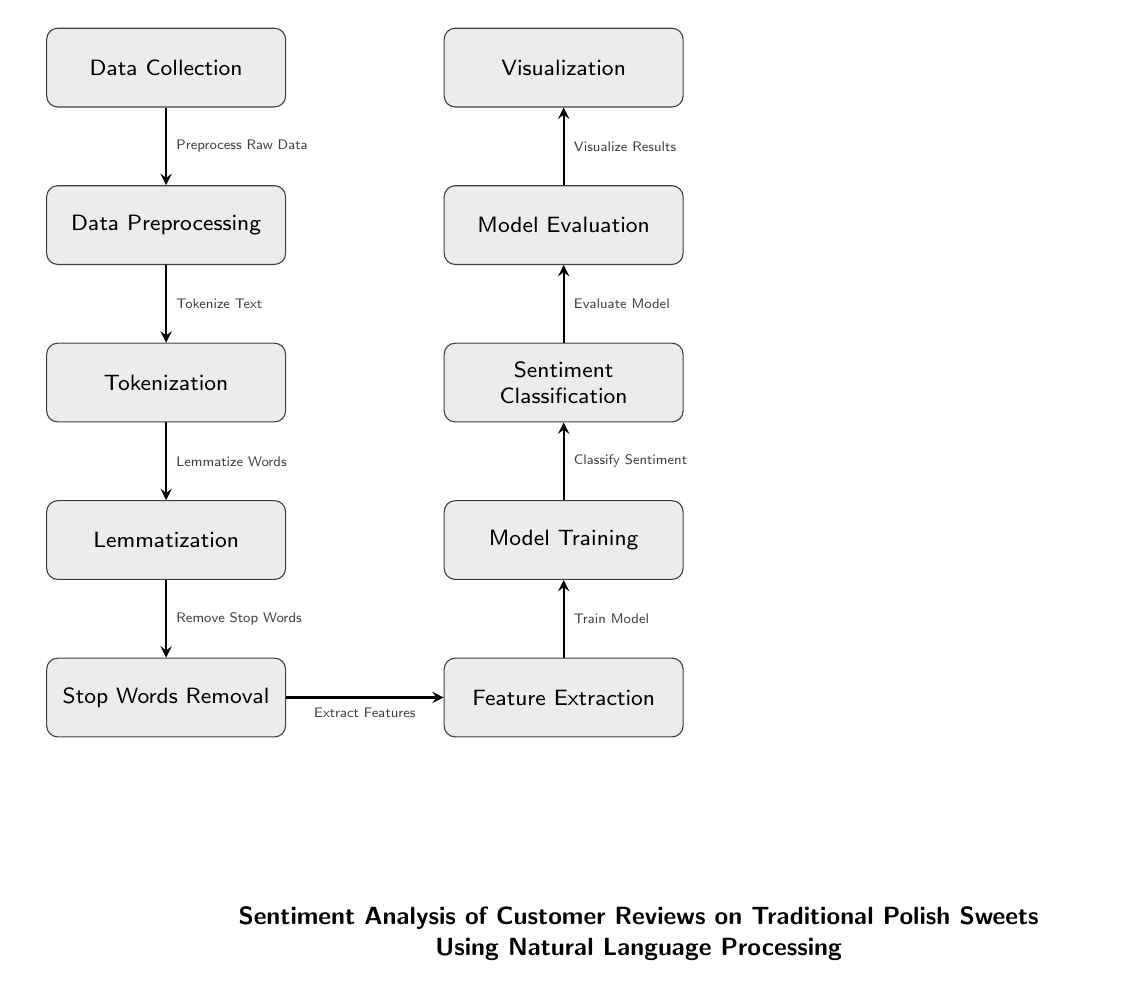What is the first step in the process? The diagram shows "Data Collection" as the first node at the top, where the process begins.
Answer: Data Collection How many processing steps are there? By counting the nodes that represent processing steps from Data Collection to Visualization, there are a total of seven steps.
Answer: Seven What follows after Lemmatization? The diagram indicates that "Stop Words Removal" follows directly after "Lemmatization."
Answer: Stop Words Removal What is the last step in the process? The final node displayed in the diagram is "Visualization," making it the last step in the process.
Answer: Visualization Which process leads to Feature Extraction? "Stop Words Removal" is the preceding process that leads directly into "Feature Extraction," as shown by the arrow connecting those two nodes.
Answer: Stop Words Removal What action occurs after Model Training? According to the diagram, the action that occurs immediately after "Model Training" is "Sentiment Classification."
Answer: Sentiment Classification How are the processes connected visually? The processes are connected by arrows, indicating the flow from one process to another in a step-by-step manner.
Answer: Arrows Which process is to the right of Tokenization? "Feature Extraction" is the process that is positioned directly to the right of the "Tokenization" node in the diagram.
Answer: Feature Extraction What is the purpose of the entire diagram? The title below the nodes states that the diagram is for conducting "Sentiment Analysis of Customer Reviews on Traditional Polish Sweets Using Natural Language Processing."
Answer: Sentiment Analysis of Customer Reviews on Traditional Polish Sweets Using Natural Language Processing 